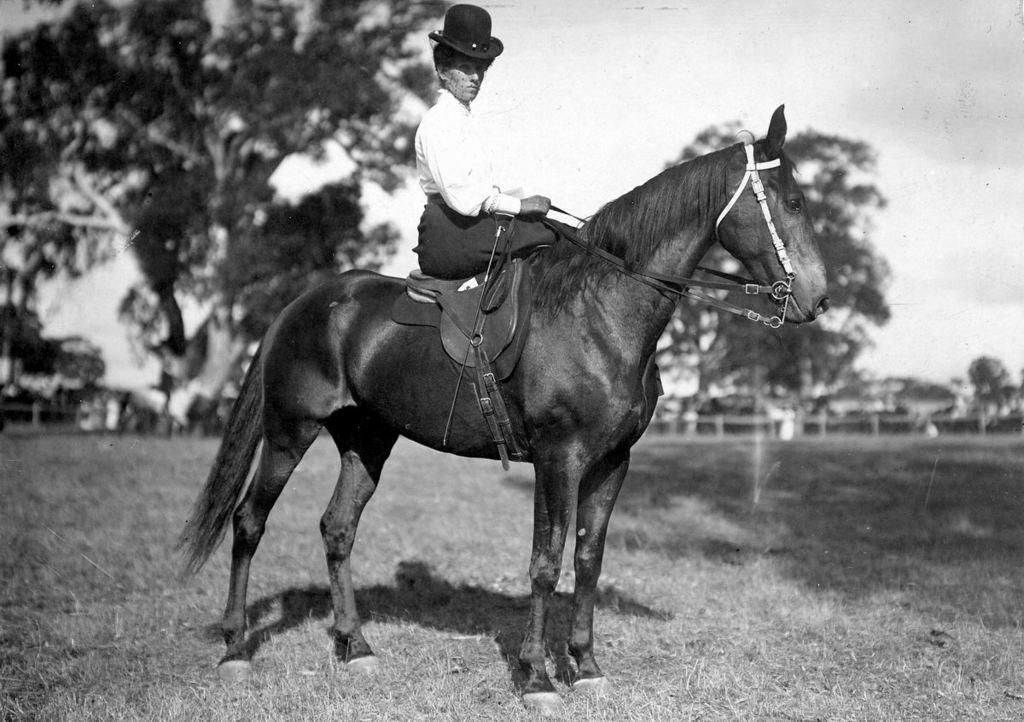Where was the picture taken? The picture was taken outside. What is the main subject in the center of the image? There is a person sitting on a horse in the center of the image. What can be seen in the background of the image? The sky and trees are visible in the background of the image, along with other unspecified items. What type of bone can be seen in the image? There is no bone present in the image. What season is depicted in the image? The provided facts do not specify the season, so it cannot be determined from the image. 